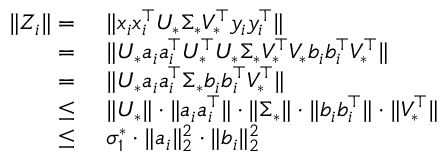<formula> <loc_0><loc_0><loc_500><loc_500>\begin{array} { r l } { \| Z _ { i } \| = } & { \| x _ { i } x _ { i } ^ { \top } U _ { * } \Sigma _ { * } V _ { * } ^ { \top } y _ { i } y _ { i } ^ { \top } \| } \\ { = } & { \| U _ { * } a _ { i } a _ { i } ^ { \top } U _ { * } ^ { \top } U _ { * } \Sigma _ { * } V _ { * } ^ { \top } V _ { * } b _ { i } b _ { i } ^ { \top } V _ { * } ^ { \top } \| } \\ { = } & { \| U _ { * } a _ { i } a _ { i } ^ { \top } \Sigma _ { * } b _ { i } b _ { i } ^ { \top } V _ { * } ^ { \top } \| } \\ { \leq } & { \| U _ { * } \| \cdot \| a _ { i } a _ { i } ^ { \top } \| \cdot \| \Sigma _ { * } \| \cdot \| b _ { i } b _ { i } ^ { \top } \| \cdot \| V _ { * } ^ { \top } \| } \\ { \leq } & { \sigma _ { 1 } ^ { * } \cdot \| a _ { i } \| _ { 2 } ^ { 2 } \cdot \| b _ { i } \| _ { 2 } ^ { 2 } } \end{array}</formula> 